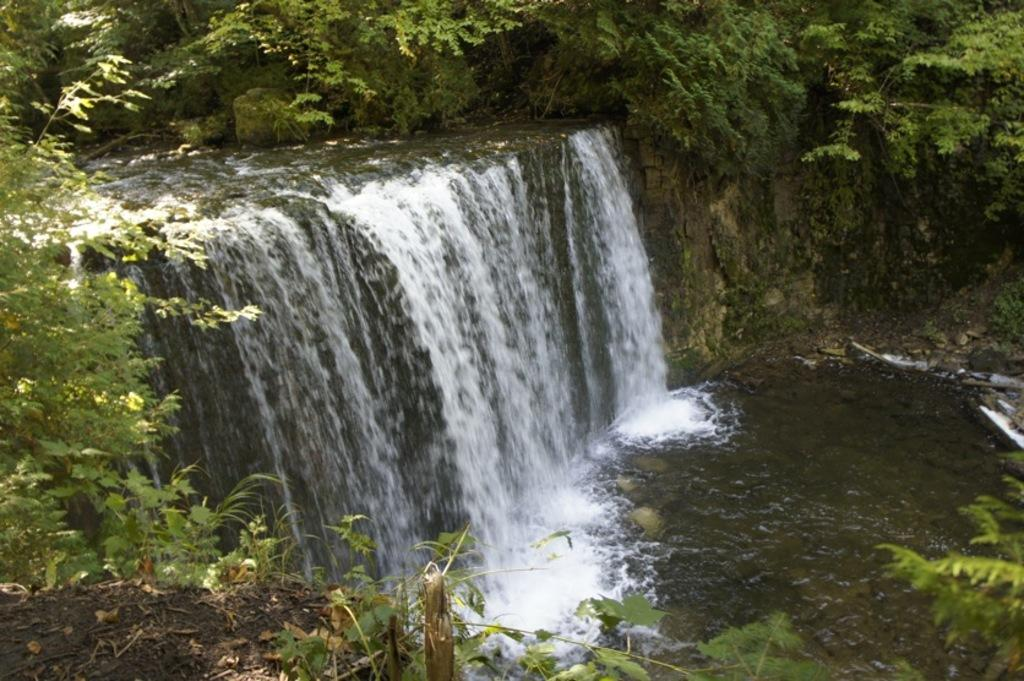What natural feature is the main subject of the image? There is a waterfall in the image. What type of vegetation can be seen in the image? There are trees in the image. What is at the base of the waterfall? There is water at the bottom of the waterfall. What is present in the foreground of the image? There is mud in the foreground of the image. What time does the clock in the image show? There is no clock present in the image, so it is not possible to determine the time. 